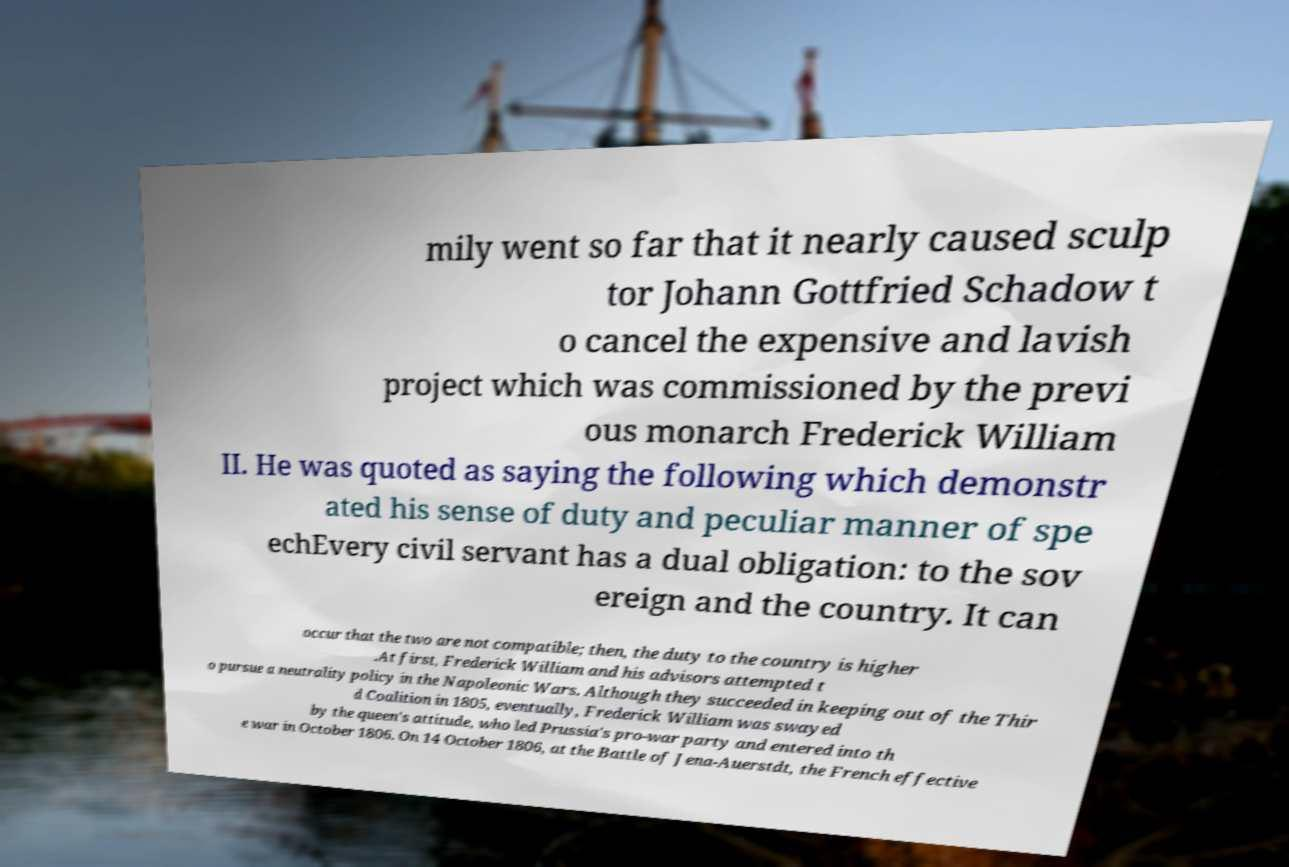Can you accurately transcribe the text from the provided image for me? mily went so far that it nearly caused sculp tor Johann Gottfried Schadow t o cancel the expensive and lavish project which was commissioned by the previ ous monarch Frederick William II. He was quoted as saying the following which demonstr ated his sense of duty and peculiar manner of spe echEvery civil servant has a dual obligation: to the sov ereign and the country. It can occur that the two are not compatible; then, the duty to the country is higher .At first, Frederick William and his advisors attempted t o pursue a neutrality policy in the Napoleonic Wars. Although they succeeded in keeping out of the Thir d Coalition in 1805, eventually, Frederick William was swayed by the queen's attitude, who led Prussia's pro-war party and entered into th e war in October 1806. On 14 October 1806, at the Battle of Jena-Auerstdt, the French effective 